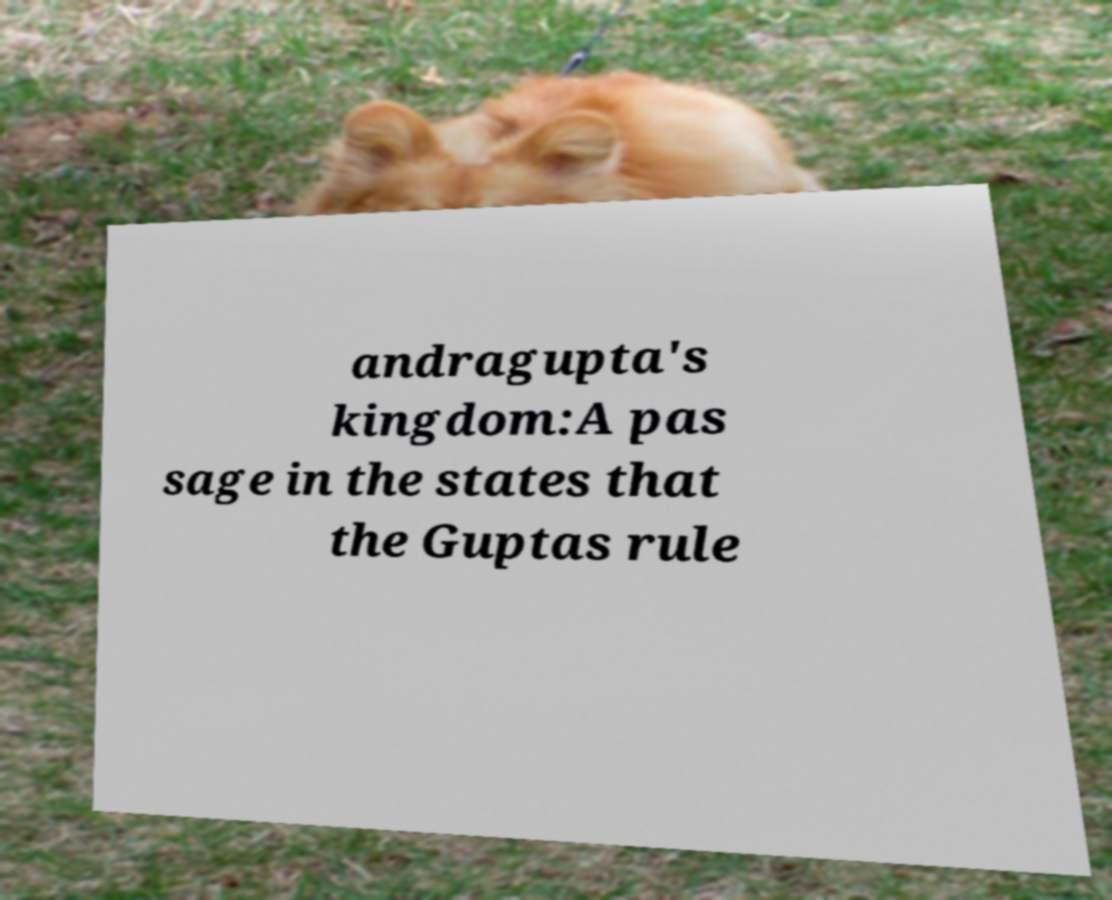Could you extract and type out the text from this image? andragupta's kingdom:A pas sage in the states that the Guptas rule 